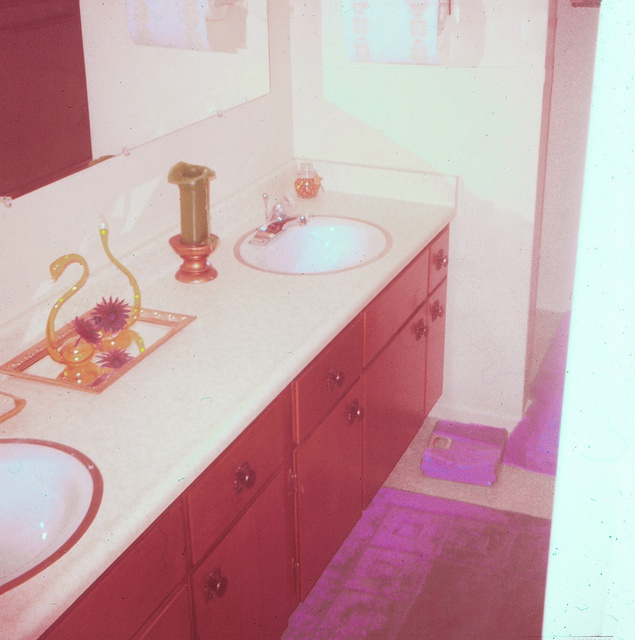Describe the objects in this image and their specific colors. I can see sink in brown, lightgray, and pink tones, sink in brown, lightgray, and pink tones, and vase in brown, lightpink, salmon, and lightgray tones in this image. 